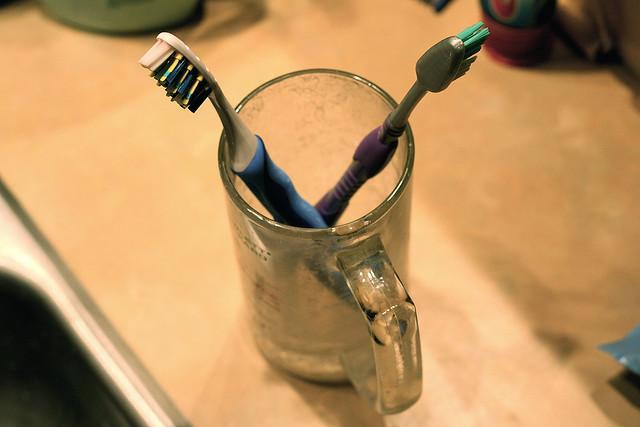How many people use this bathroom? Please explain your reasoning. two. There are clearly two tooth brushes. 